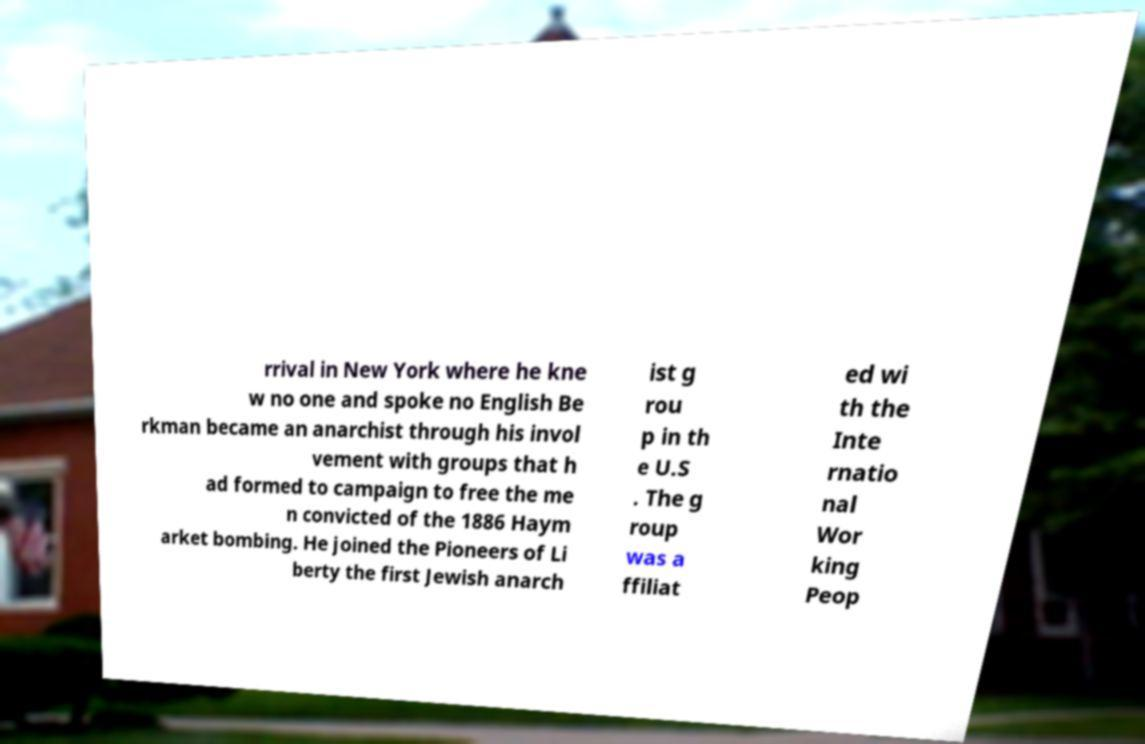Please identify and transcribe the text found in this image. rrival in New York where he kne w no one and spoke no English Be rkman became an anarchist through his invol vement with groups that h ad formed to campaign to free the me n convicted of the 1886 Haym arket bombing. He joined the Pioneers of Li berty the first Jewish anarch ist g rou p in th e U.S . The g roup was a ffiliat ed wi th the Inte rnatio nal Wor king Peop 